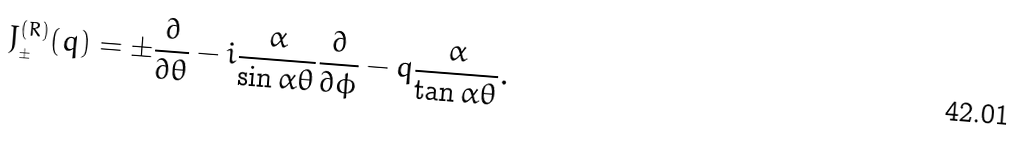Convert formula to latex. <formula><loc_0><loc_0><loc_500><loc_500>J _ { _ { \pm } } ^ { ( R ) } ( q ) = \pm \frac { \partial } { \partial \theta } - i \frac { \alpha } { \sin \alpha \theta } \frac { \partial } { \partial \phi } - q \frac { \alpha } { \tan \alpha \theta } .</formula> 